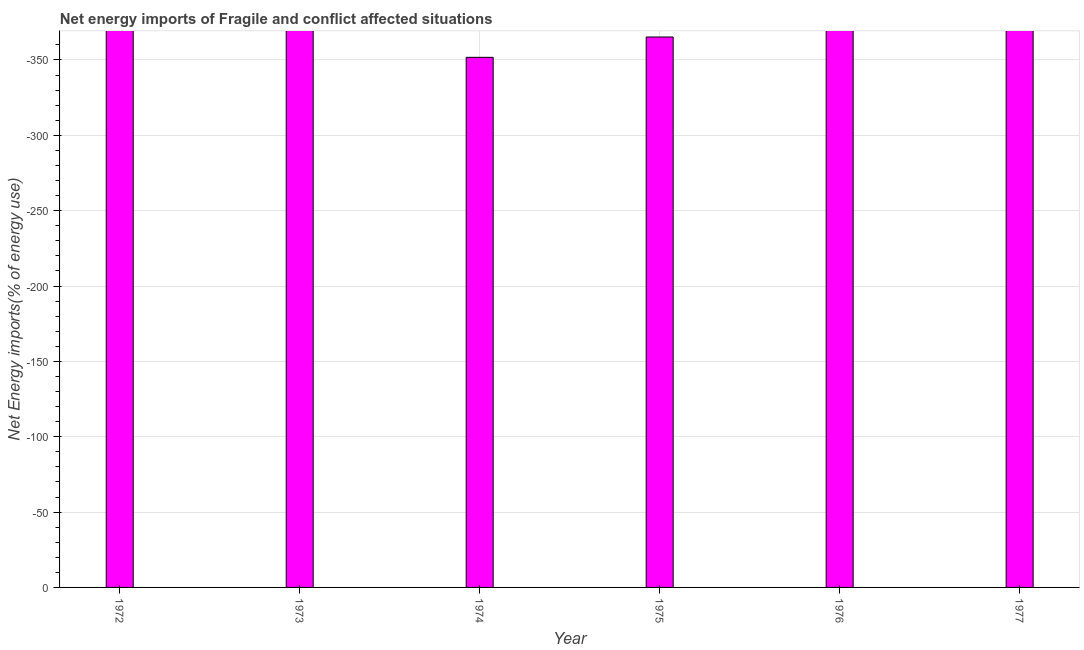Does the graph contain any zero values?
Offer a terse response. Yes. What is the title of the graph?
Make the answer very short. Net energy imports of Fragile and conflict affected situations. What is the label or title of the Y-axis?
Make the answer very short. Net Energy imports(% of energy use). What is the median energy imports?
Give a very brief answer. 0. How many bars are there?
Your response must be concise. 0. How many years are there in the graph?
Your response must be concise. 6. What is the Net Energy imports(% of energy use) of 1972?
Offer a terse response. 0. What is the Net Energy imports(% of energy use) in 1973?
Your answer should be compact. 0. What is the Net Energy imports(% of energy use) in 1976?
Ensure brevity in your answer.  0. 